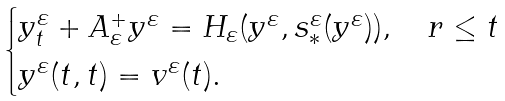<formula> <loc_0><loc_0><loc_500><loc_500>\begin{cases} y _ { t } ^ { \varepsilon } + A _ { \varepsilon } ^ { + } y ^ { \varepsilon } = H _ { \varepsilon } ( y ^ { \varepsilon } , s _ { * } ^ { \varepsilon } ( y ^ { \varepsilon } ) ) , \quad r \leq t \\ y ^ { \varepsilon } ( t , t ) = v ^ { \varepsilon } ( t ) . \end{cases}</formula> 